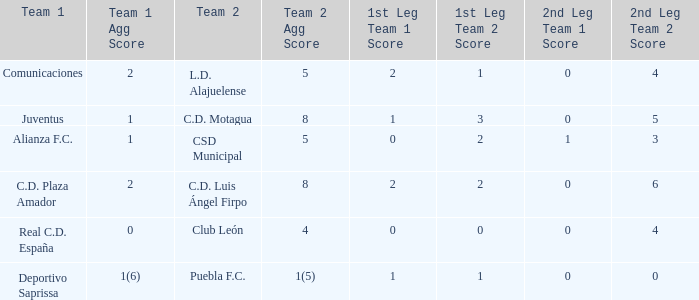What is the 2nd leg of the Comunicaciones team? 0 - 4. 